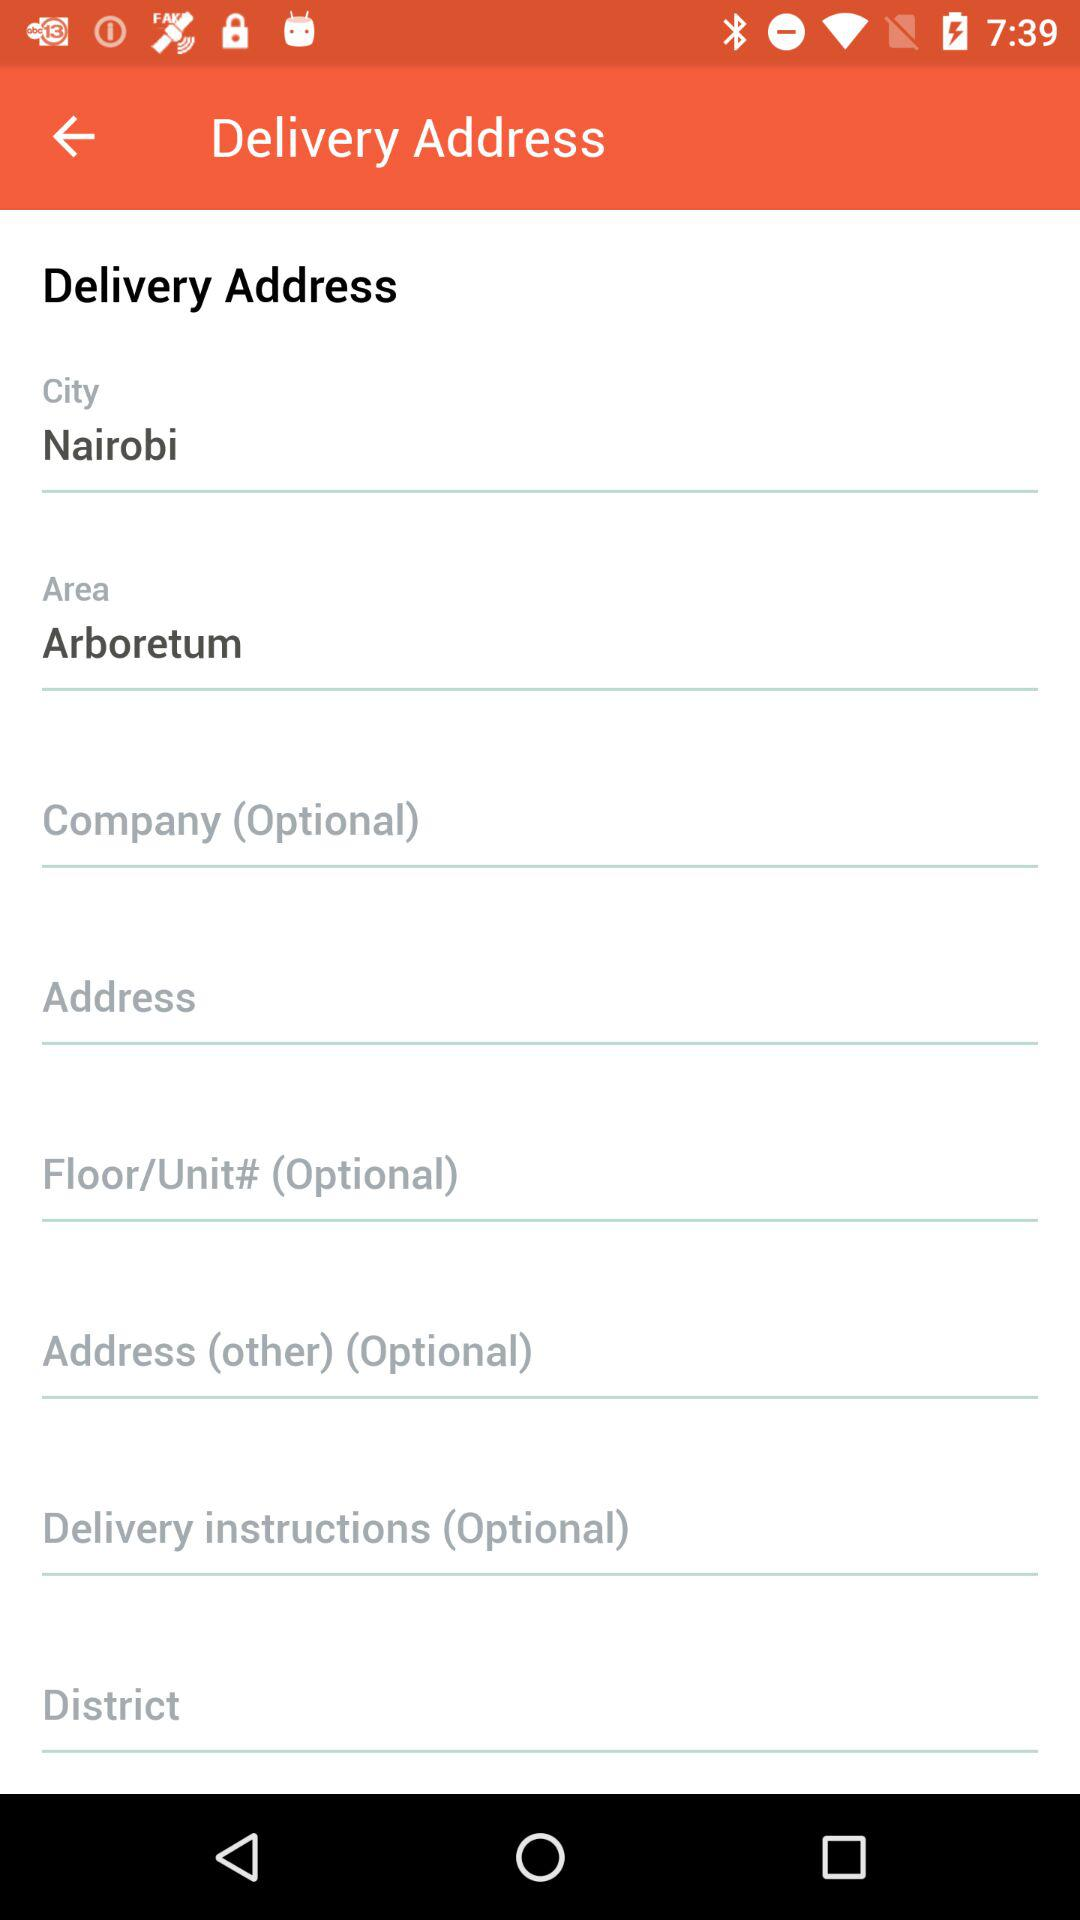Which company is the postal service assigned to the delivery?
When the provided information is insufficient, respond with <no answer>. <no answer> 